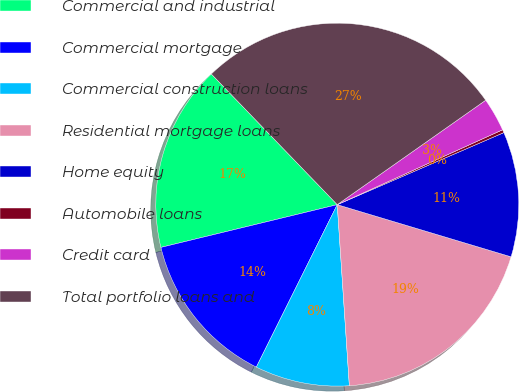<chart> <loc_0><loc_0><loc_500><loc_500><pie_chart><fcel>Commercial and industrial<fcel>Commercial mortgage<fcel>Commercial construction loans<fcel>Residential mortgage loans<fcel>Home equity<fcel>Automobile loans<fcel>Credit card<fcel>Total portfolio loans and<nl><fcel>16.58%<fcel>13.86%<fcel>8.42%<fcel>19.3%<fcel>11.14%<fcel>0.27%<fcel>2.99%<fcel>27.45%<nl></chart> 